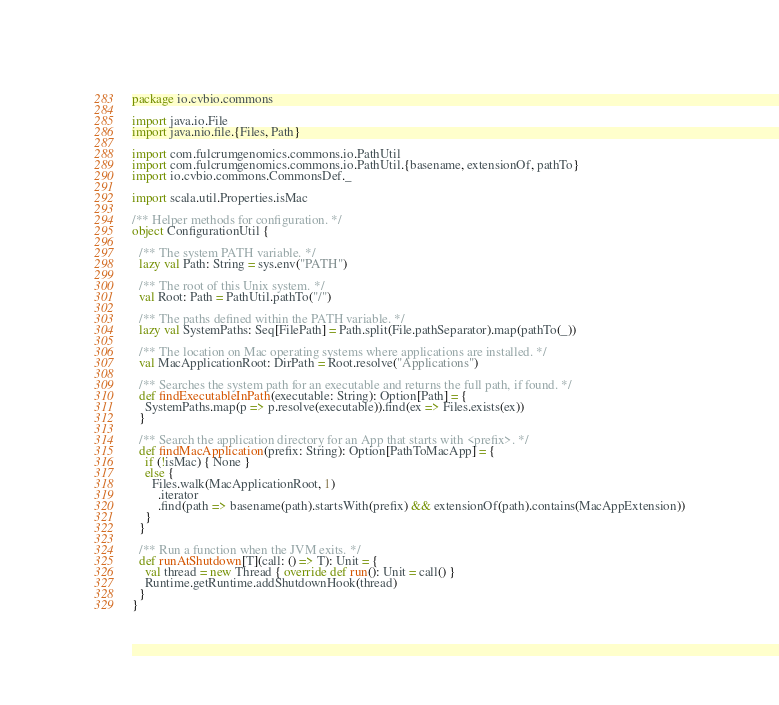<code> <loc_0><loc_0><loc_500><loc_500><_Scala_>package io.cvbio.commons

import java.io.File
import java.nio.file.{Files, Path}

import com.fulcrumgenomics.commons.io.PathUtil
import com.fulcrumgenomics.commons.io.PathUtil.{basename, extensionOf, pathTo}
import io.cvbio.commons.CommonsDef._

import scala.util.Properties.isMac

/** Helper methods for configuration. */
object ConfigurationUtil {

  /** The system PATH variable. */
  lazy val Path: String = sys.env("PATH")

  /** The root of this Unix system. */
  val Root: Path = PathUtil.pathTo("/")

  /** The paths defined within the PATH variable. */
  lazy val SystemPaths: Seq[FilePath] = Path.split(File.pathSeparator).map(pathTo(_))

  /** The location on Mac operating systems where applications are installed. */
  val MacApplicationRoot: DirPath = Root.resolve("Applications")

  /** Searches the system path for an executable and returns the full path, if found. */
  def findExecutableInPath(executable: String): Option[Path] = {
    SystemPaths.map(p => p.resolve(executable)).find(ex => Files.exists(ex))
  }

  /** Search the application directory for an App that starts with <prefix>. */
  def findMacApplication(prefix: String): Option[PathToMacApp] = {
    if (!isMac) { None }
    else {
      Files.walk(MacApplicationRoot, 1)
        .iterator
        .find(path => basename(path).startsWith(prefix) && extensionOf(path).contains(MacAppExtension))
    }
  }

  /** Run a function when the JVM exits. */
  def runAtShutdown[T](call: () => T): Unit = {
    val thread = new Thread { override def run(): Unit = call() }
    Runtime.getRuntime.addShutdownHook(thread)
  }
}
</code> 